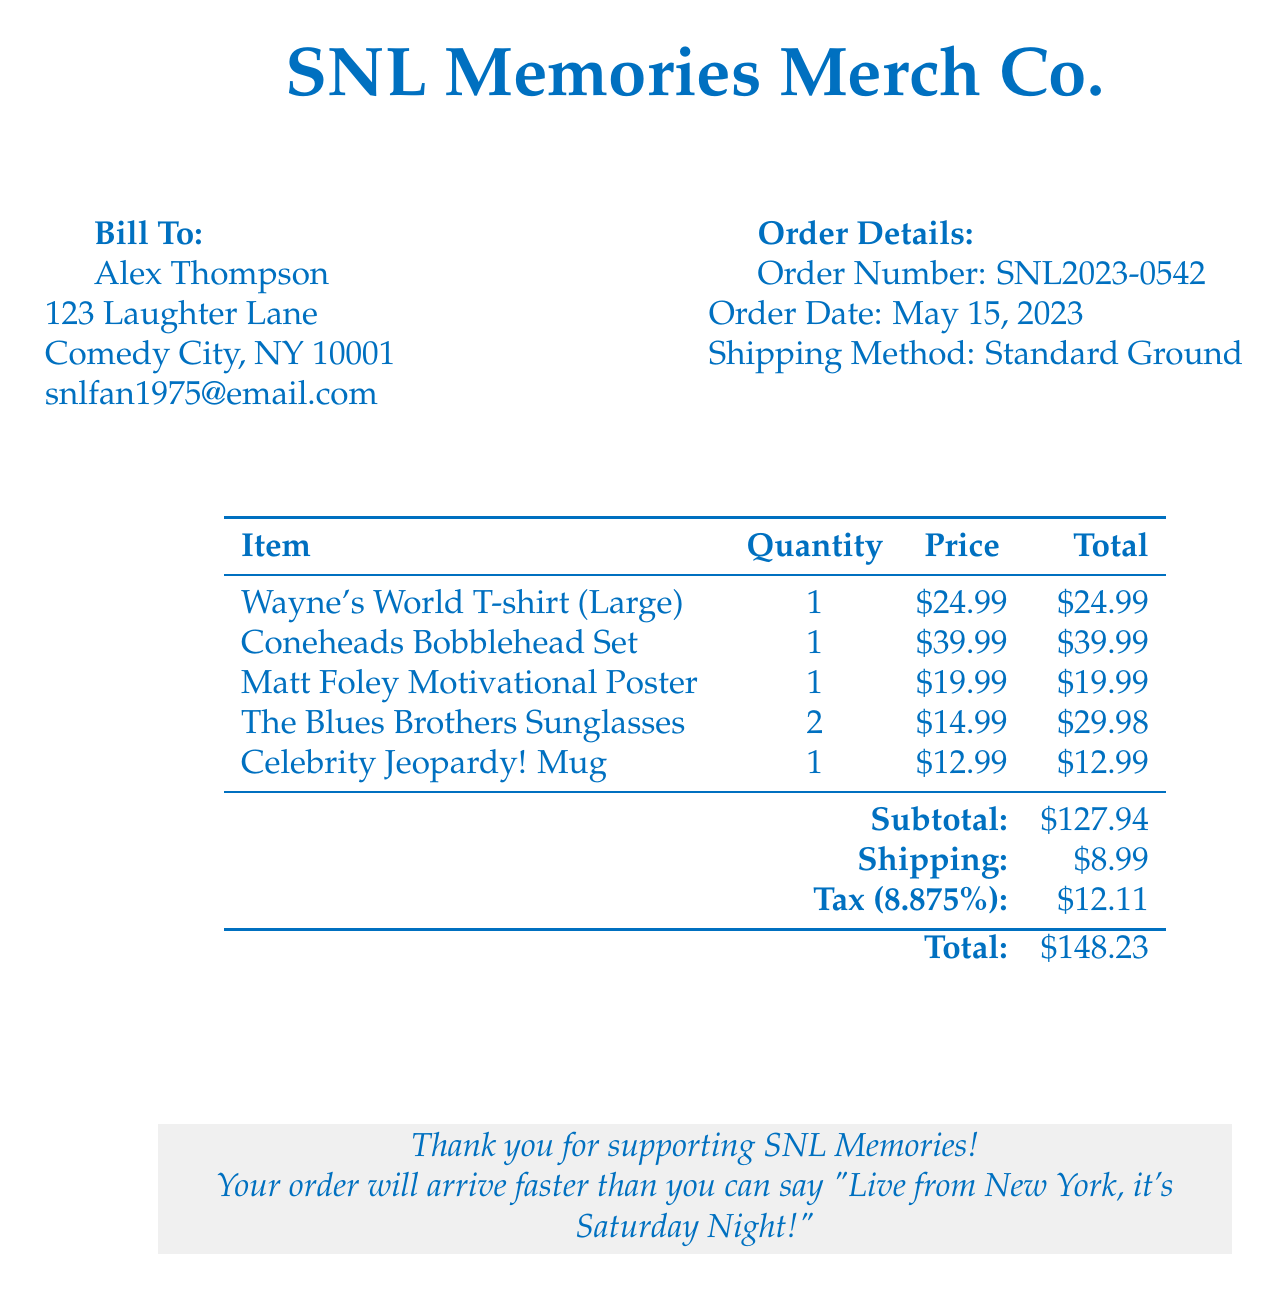What is the order number? The order number is specified in the order details section of the document.
Answer: SNL2023-0542 Who is the bill addressed to? The bill to section includes the recipient's name.
Answer: Alex Thompson What is the shipping method? The shipping method is listed under the order details section.
Answer: Standard Ground How much is the subtotal? The subtotal is calculated from the total prices of the items listed.
Answer: $127.94 What is the total amount due? The total amount is the final figure at the bottom of the bill.
Answer: $148.23 How many Wayne's World T-shirts were ordered? The quantity for this item is listed in the itemized section.
Answer: 1 What is the tax rate applied to this order? The tax rate is mentioned next to the tax total in the document.
Answer: 8.875% What item was included in the order with the highest price? The item prices are listed, and the highest price can be identified from the list.
Answer: Coneheads Bobblehead Set How many items were ordered in total? The items can be summed from the quantity column in the itemized list.
Answer: 6 